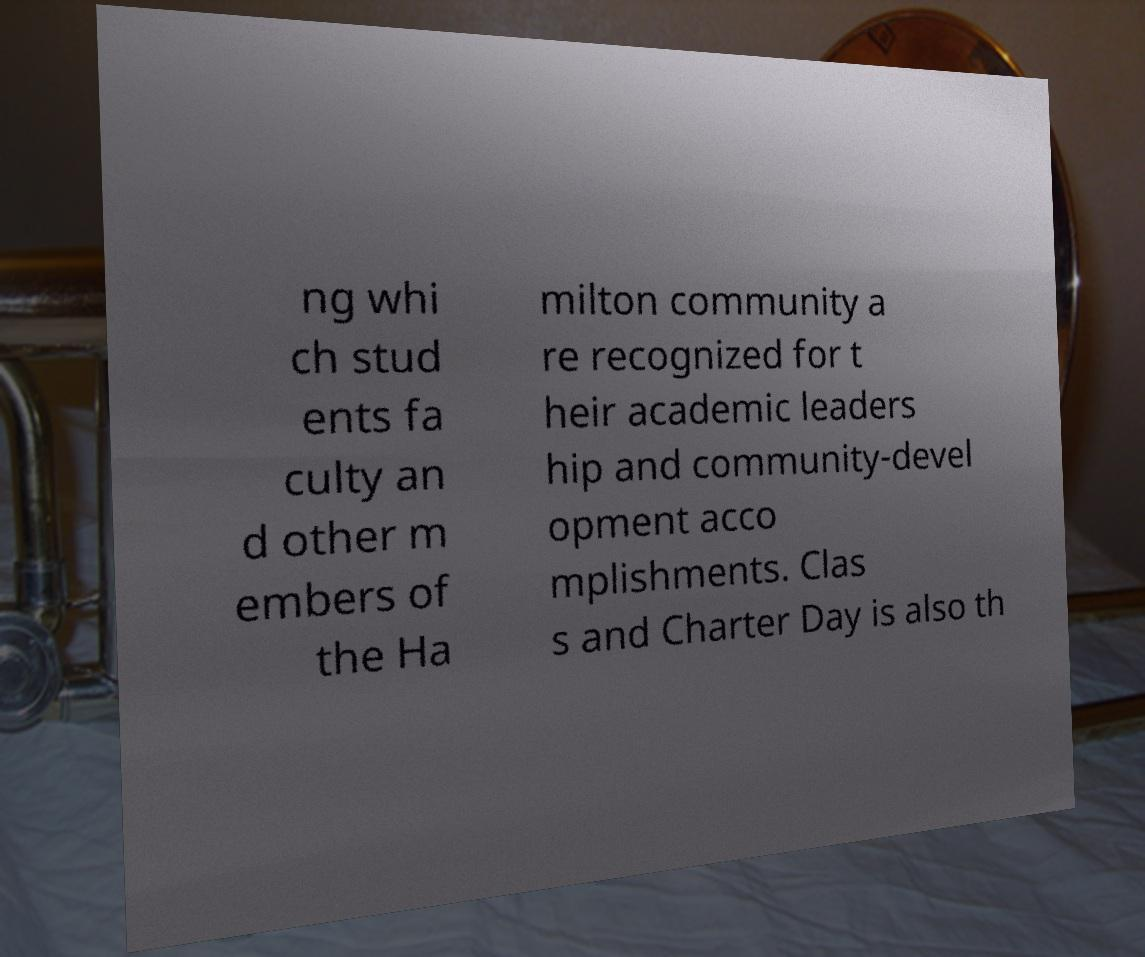Can you accurately transcribe the text from the provided image for me? ng whi ch stud ents fa culty an d other m embers of the Ha milton community a re recognized for t heir academic leaders hip and community-devel opment acco mplishments. Clas s and Charter Day is also th 